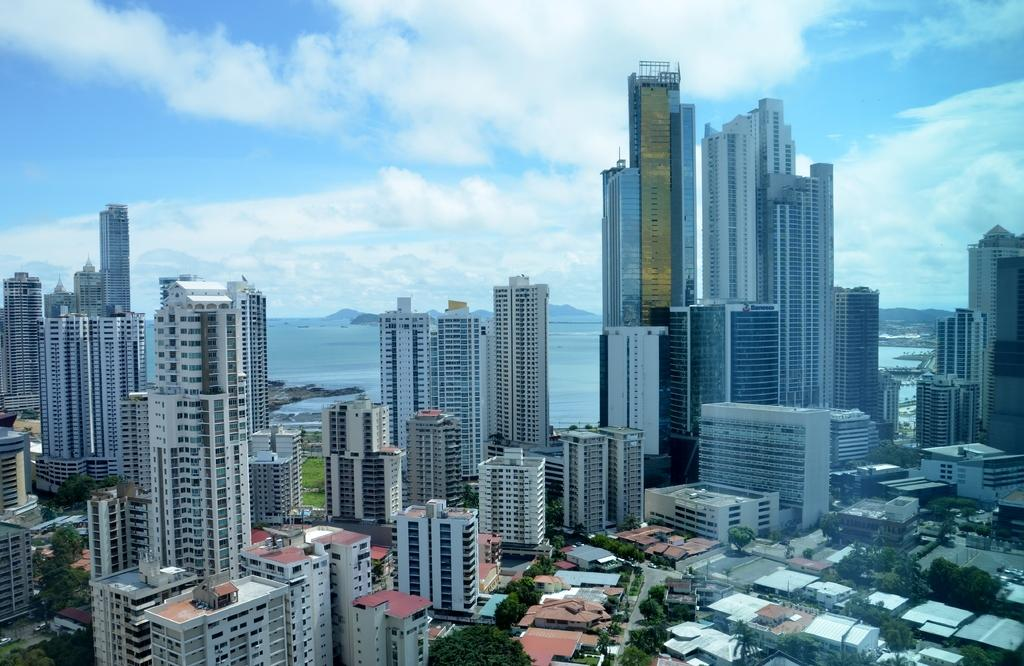What type of structures can be seen in the image? There are buildings and skyscrapers in the image. What other natural elements are present in the image? There are trees and water visible behind the buildings. What can be seen in the background of the image? There are mountains in the background of the image. What is visible at the top of the image? The sky is visible at the top of the image. How many eggs are visible on the elbow of the person in the image? There is no person or elbow present in the image, and therefore no eggs can be observed. 